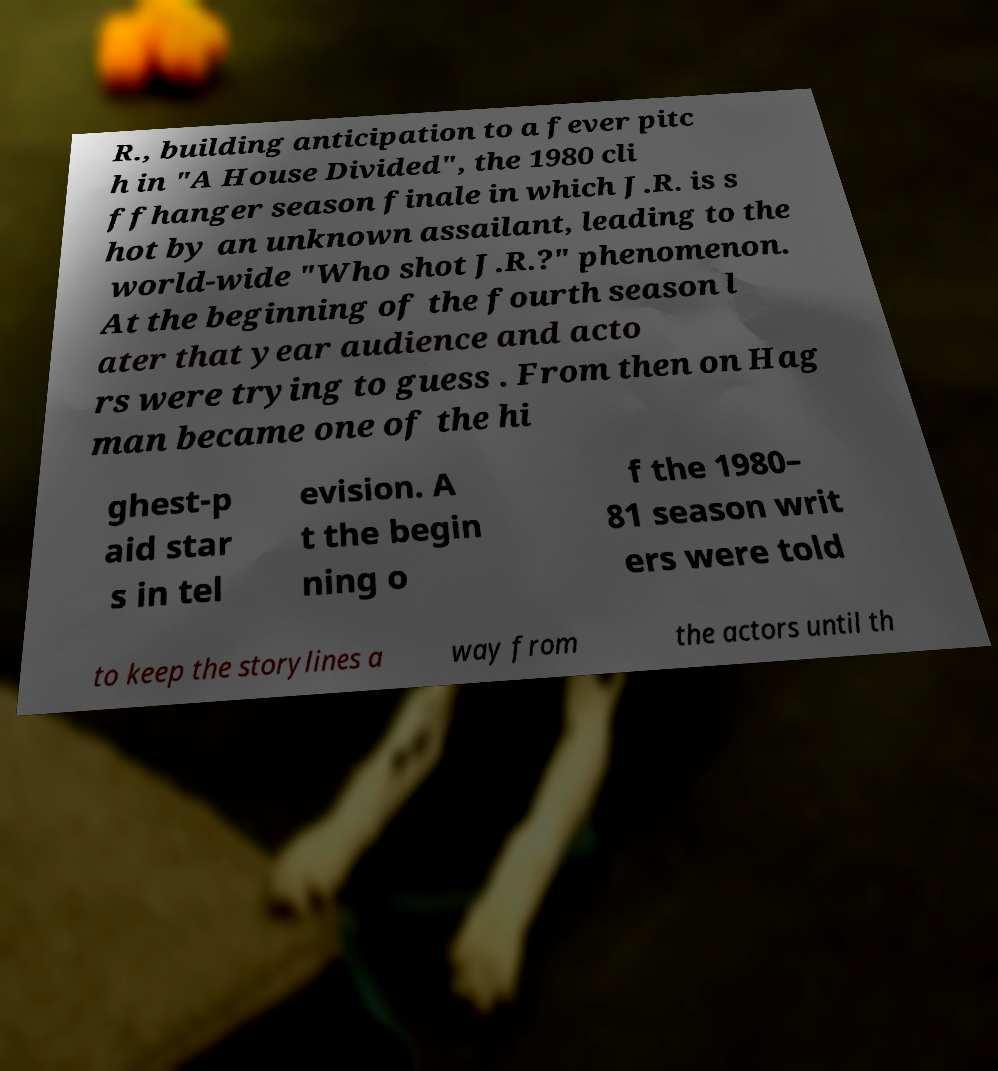For documentation purposes, I need the text within this image transcribed. Could you provide that? R., building anticipation to a fever pitc h in "A House Divided", the 1980 cli ffhanger season finale in which J.R. is s hot by an unknown assailant, leading to the world-wide "Who shot J.R.?" phenomenon. At the beginning of the fourth season l ater that year audience and acto rs were trying to guess . From then on Hag man became one of the hi ghest-p aid star s in tel evision. A t the begin ning o f the 1980– 81 season writ ers were told to keep the storylines a way from the actors until th 